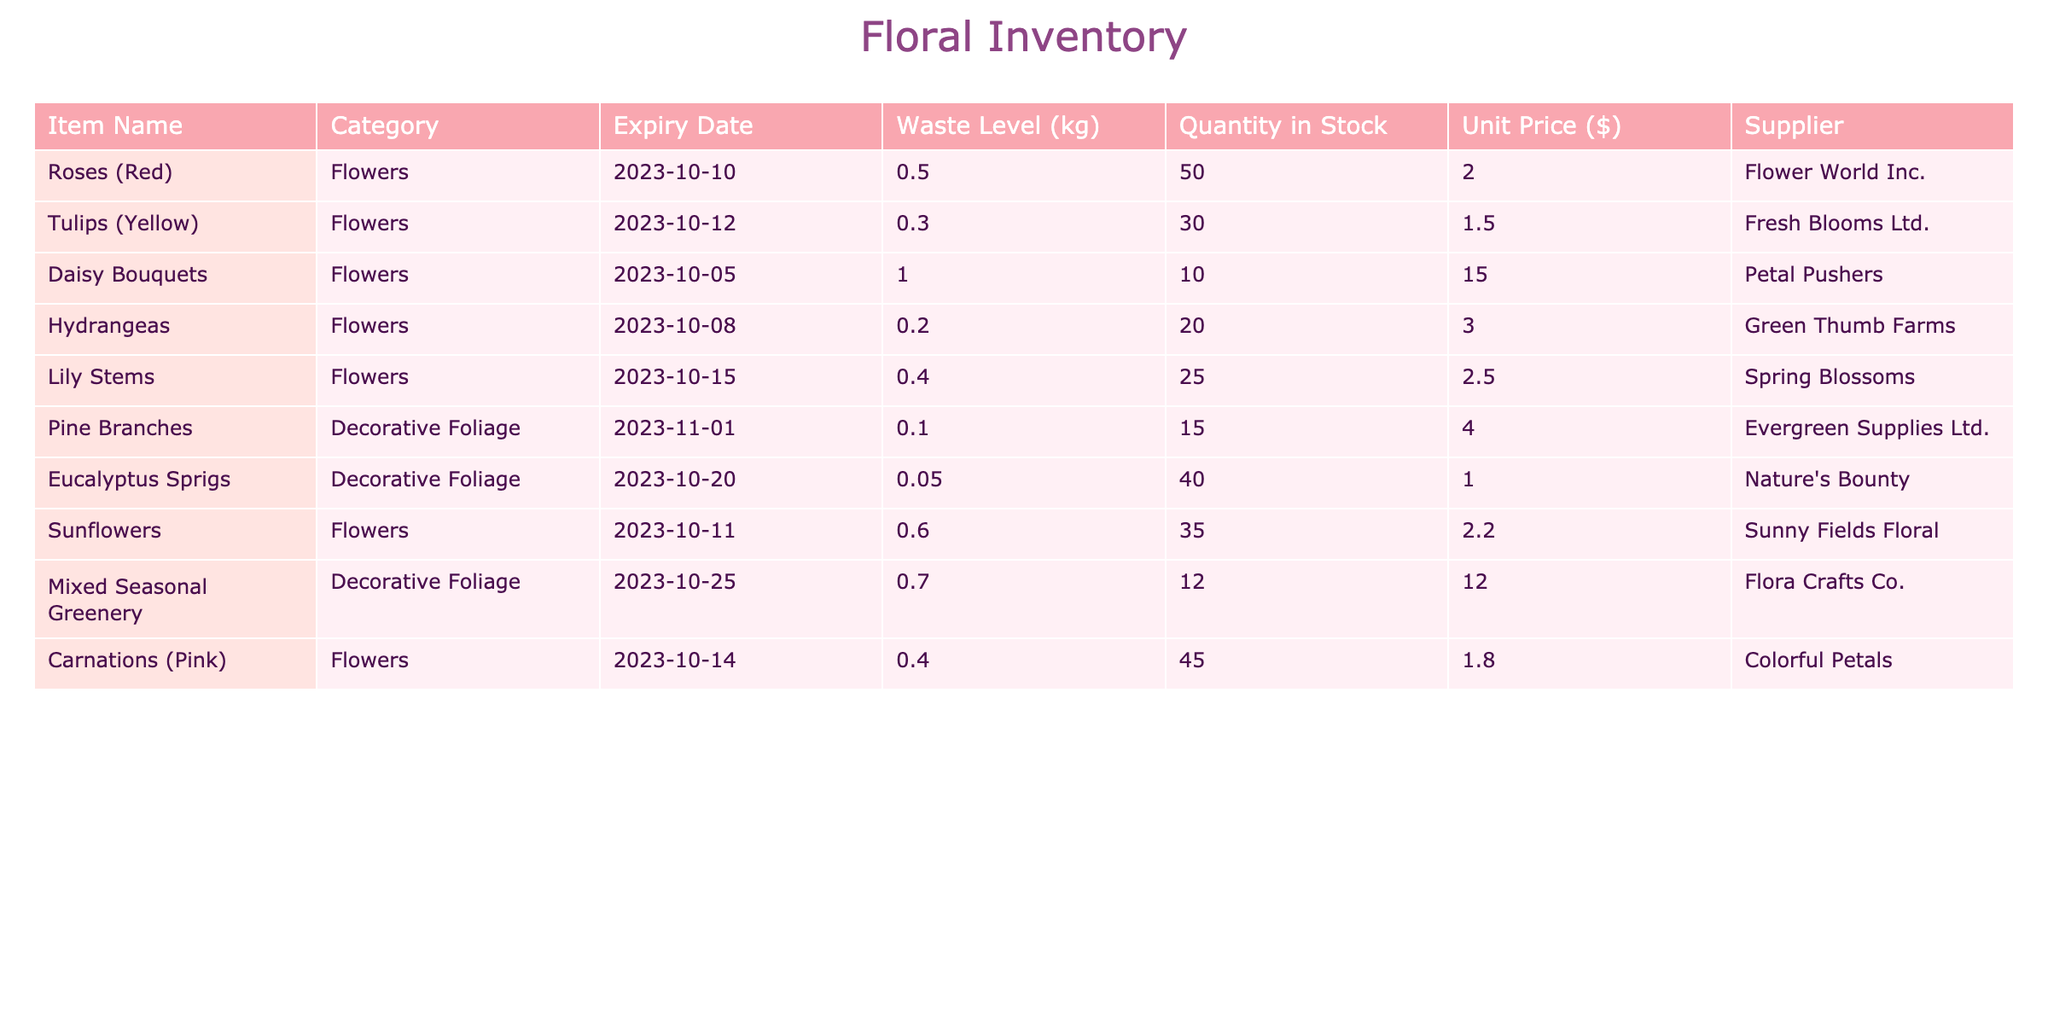What is the expiry date of Daisy Bouquets? The table lists Daisy Bouquets under the "Item Name" column, and the corresponding "Expiry Date" for that row is 2023-10-05.
Answer: 2023-10-05 Which flower has the highest waste level? By examining the "Waste Level (kg)" column, I see that Daisy Bouquets has the highest waste level at 1.0 kg.
Answer: Daisy Bouquets What is the total quantity of stock for all flowers? The total quantity can be found by summing the "Quantity in Stock" for all items in the "Flowers" category: 50 + 30 + 10 + 20 + 25 + 35 + 45 = 215.
Answer: 215 Is there any item from Fresh Blooms Ltd. in stock? Checking the "Supplier" column for Fresh Blooms Ltd., I find that there is one item, "Tulips (Yellow)", in stock with a quantity of 30.
Answer: Yes How much waste is accounted for amongst items that expire before 2023-10-11? The items before this expiry date are Daisy Bouquets (1.0 kg), Hydrangeas (0.2 kg), and Sunflowers (0.6 kg). Adding these waste levels gives 1.0 + 0.2 + 0.6 = 1.8 kg total waste.
Answer: 1.8 kg What is the difference in unit price between the most expensive and the least expensive flower item? The most expensive flower is Daisy Bouquets at $15.00, and the least expensive is Tulips (Yellow) at $1.50. The difference is 15.00 - 1.50 = 13.50 dollars.
Answer: 13.50 Which flower item has the longest shelf life? To find this, I compare the expiry dates. The item with the latest expiry date is Lily Stems, expiring on 2023-10-15.
Answer: Lily Stems Are there any items from Evergreen Supplies Ltd. that are flowers? Looking under the "Supplier" column, the item from Evergreen Supplies Ltd. is Pine Branches, which are not flowers.
Answer: No How many items have a waste level of less than 0.5 kg? Analyzing the "Waste Level (kg)" column, the items that qualify are Tulips (0.3 kg), Hydrangeas (0.2 kg), and Eucalyptus Sprigs (0.05 kg). Counting these gives us three items.
Answer: 3 